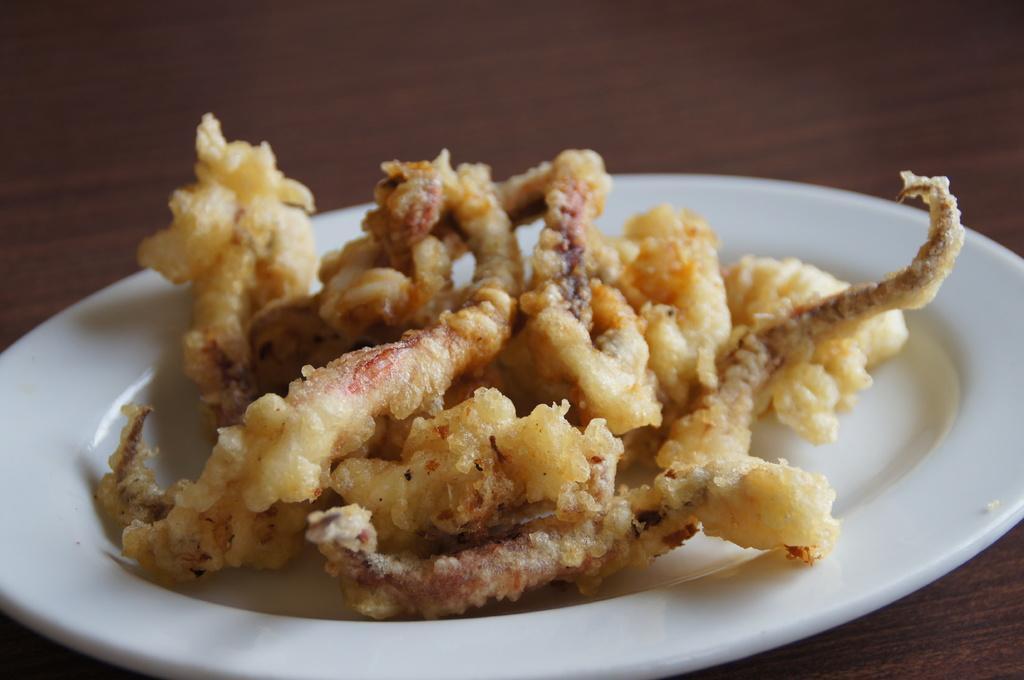Please provide a concise description of this image. In this image we can see a plate with some food item on the table. 